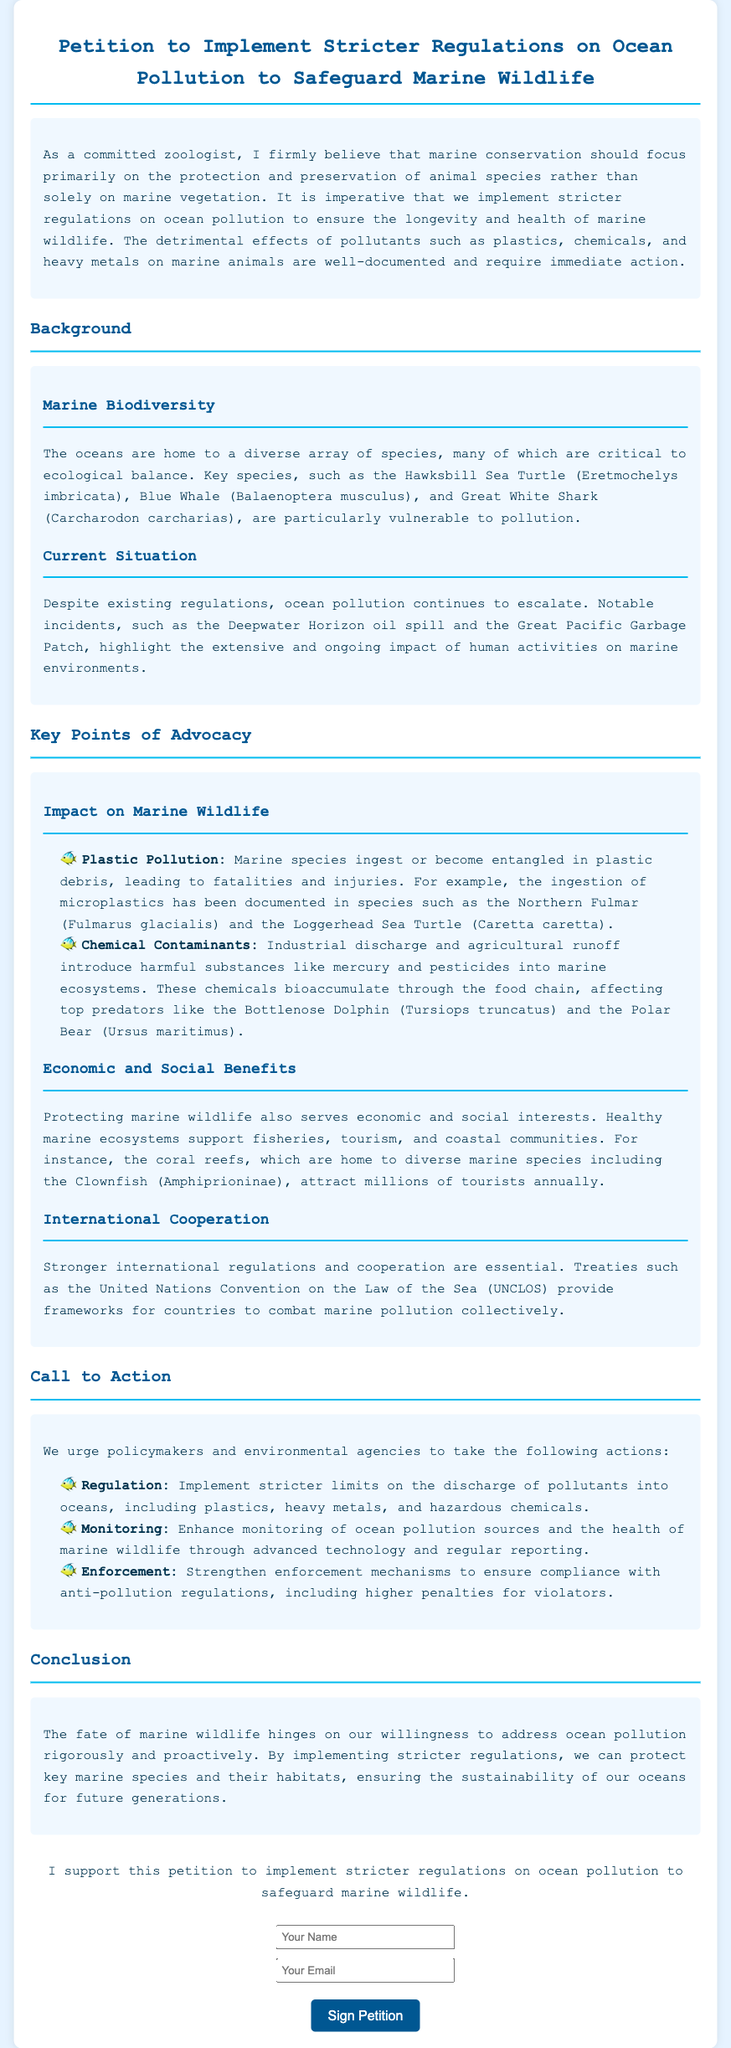What is the name of the turtle mentioned as vulnerable to pollution? The document states that the Hawksbill Sea Turtle is particularly vulnerable to pollution.
Answer: Hawksbill Sea Turtle What are two types of contaminants discussed in the petition? The petition discusses plastic pollution and chemical contaminants as harmful to marine wildlife.
Answer: Plastic pollution, chemical contaminants What is one economic benefit of protecting marine wildlife? The document mentions that healthy marine ecosystems support fisheries and tourism as economic benefits.
Answer: Fisheries and tourism How many actions are urged in the Call to Action section? The Call to Action section lists three actions that policymakers and environmental agencies are urged to take.
Answer: Three What incident is highlighted to show the impact of human activities on marine environments? The document mentions the Deepwater Horizon oil spill as a notable incident reflecting ongoing pollution issues.
Answer: Deepwater Horizon oil spill Who are the top predators affected by chemical contaminants? The petition specifies that top predators such as the Bottlenose Dolphin and the Polar Bear are affected by these contaminants.
Answer: Bottlenose Dolphin, Polar Bear What is the purpose of the petition? The petition aims to implement stricter regulations on ocean pollution to protect marine wildlife.
Answer: Implement stricter regulations on ocean pollution Which international treaty is mentioned in the document? The petition refers to the United Nations Convention on the Law of the Sea as a framework for combatting marine pollution.
Answer: United Nations Convention on the Law of the Sea 